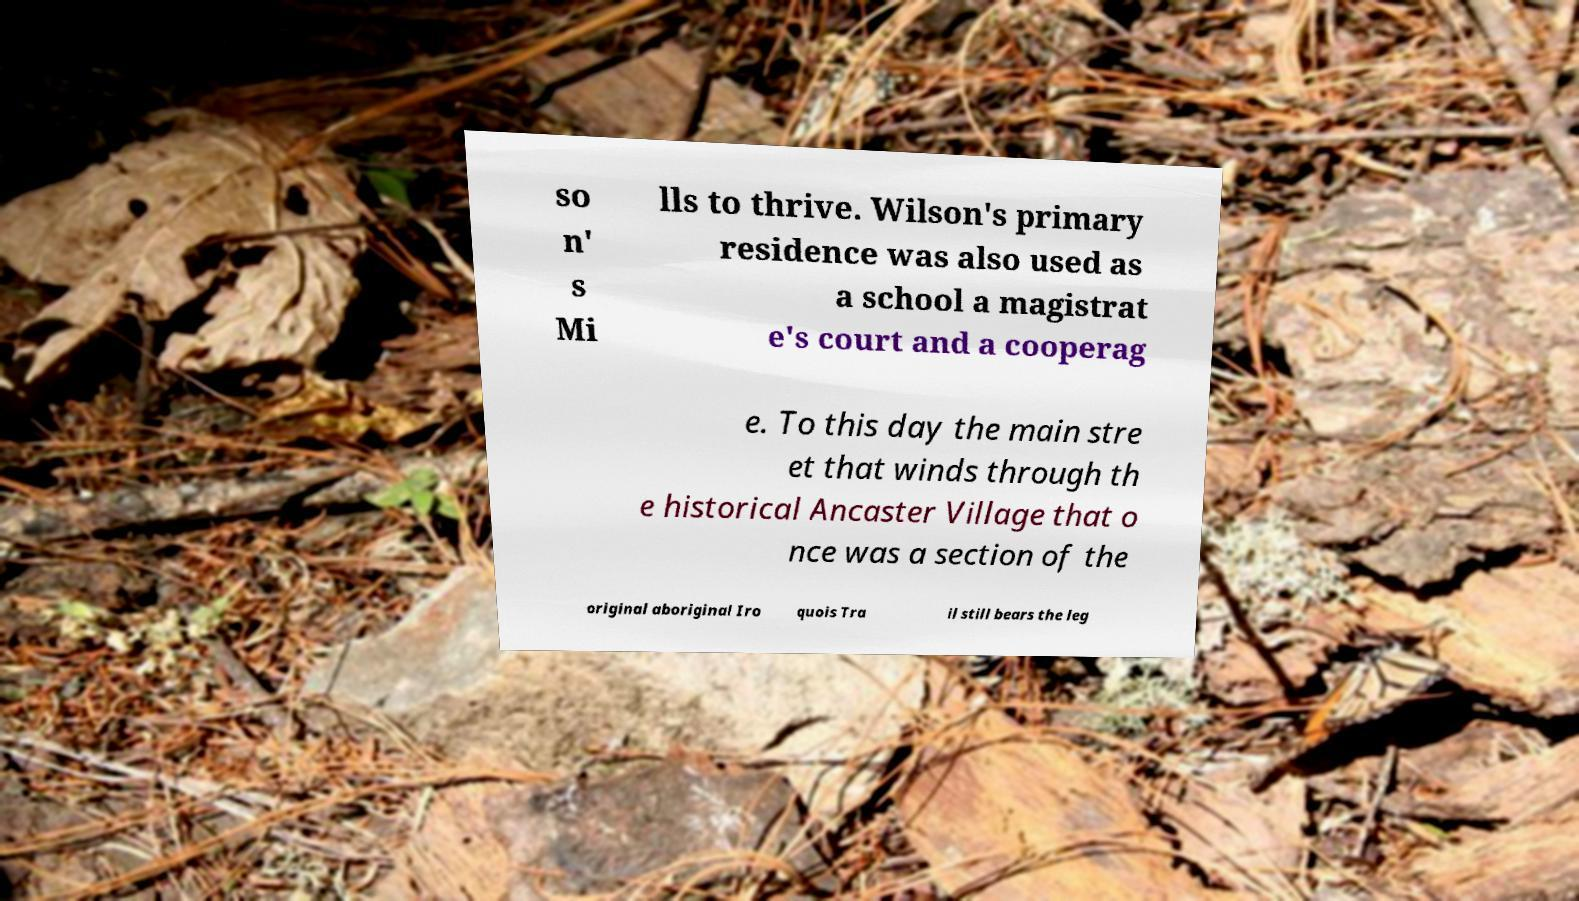I need the written content from this picture converted into text. Can you do that? so n' s Mi lls to thrive. Wilson's primary residence was also used as a school a magistrat e's court and a cooperag e. To this day the main stre et that winds through th e historical Ancaster Village that o nce was a section of the original aboriginal Iro quois Tra il still bears the leg 